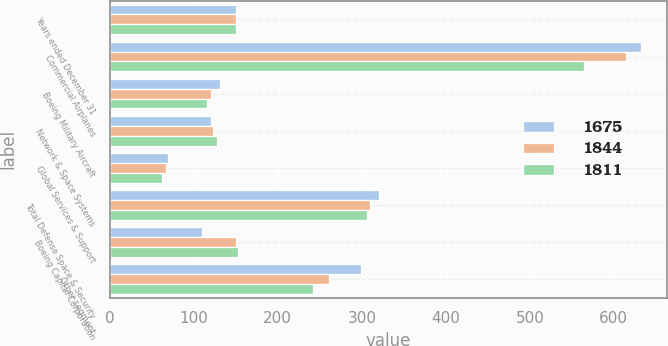<chart> <loc_0><loc_0><loc_500><loc_500><stacked_bar_chart><ecel><fcel>Years ended December 31<fcel>Commercial Airplanes<fcel>Boeing Military Aircraft<fcel>Network & Space Systems<fcel>Global Services & Support<fcel>Total Defense Space & Security<fcel>Boeing Capital Corporation<fcel>Other segment<nl><fcel>1675<fcel>150<fcel>632<fcel>131<fcel>120<fcel>69<fcel>320<fcel>110<fcel>299<nl><fcel>1844<fcel>150<fcel>614<fcel>120<fcel>123<fcel>67<fcel>310<fcel>150<fcel>261<nl><fcel>1811<fcel>150<fcel>565<fcel>116<fcel>128<fcel>62<fcel>306<fcel>153<fcel>242<nl></chart> 